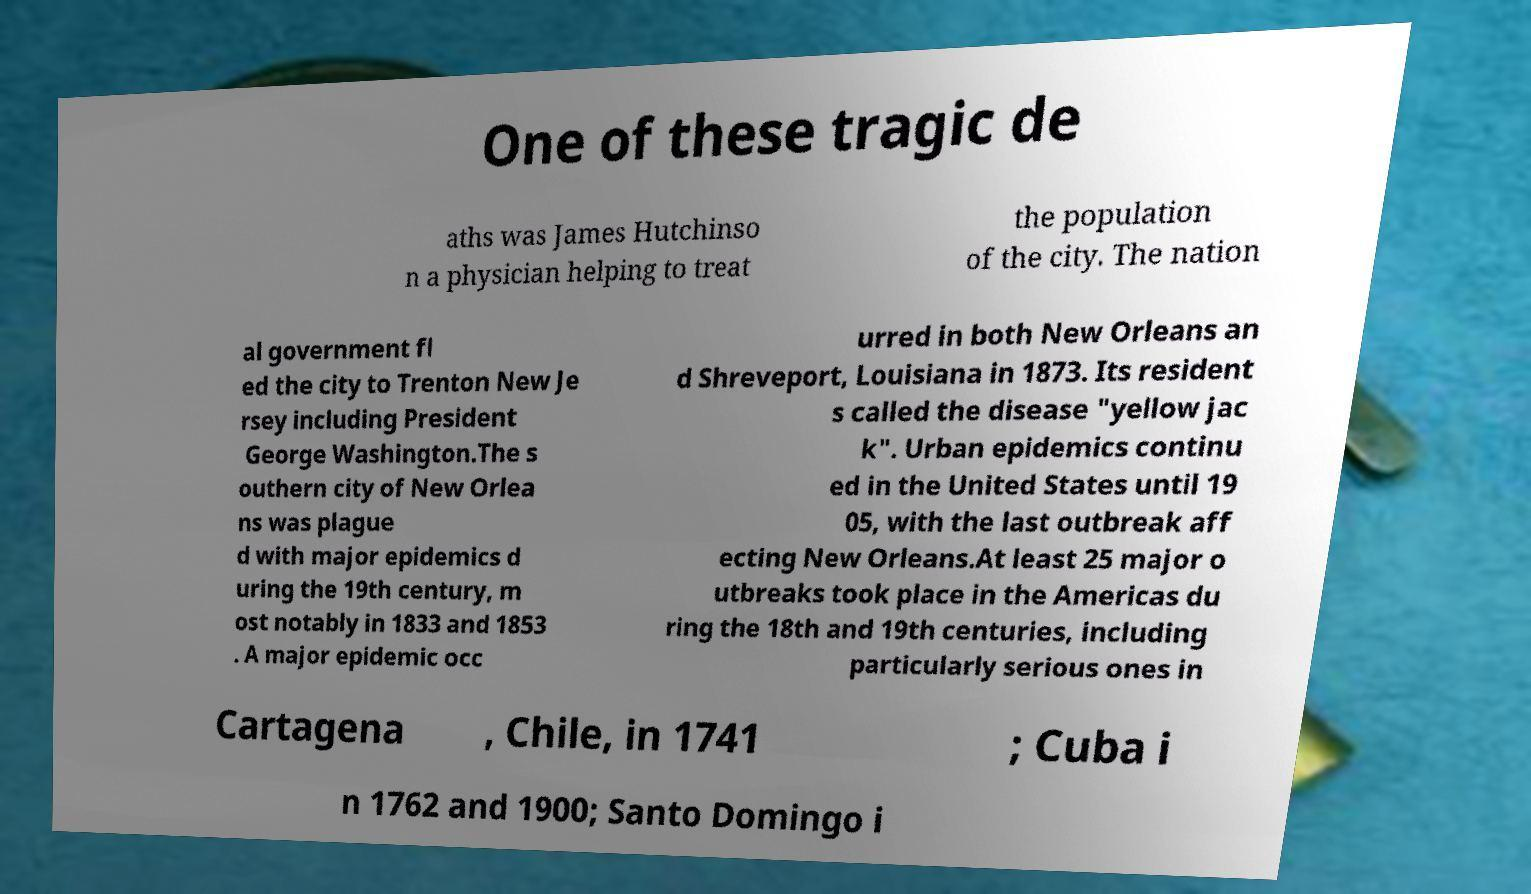Could you extract and type out the text from this image? One of these tragic de aths was James Hutchinso n a physician helping to treat the population of the city. The nation al government fl ed the city to Trenton New Je rsey including President George Washington.The s outhern city of New Orlea ns was plague d with major epidemics d uring the 19th century, m ost notably in 1833 and 1853 . A major epidemic occ urred in both New Orleans an d Shreveport, Louisiana in 1873. Its resident s called the disease "yellow jac k". Urban epidemics continu ed in the United States until 19 05, with the last outbreak aff ecting New Orleans.At least 25 major o utbreaks took place in the Americas du ring the 18th and 19th centuries, including particularly serious ones in Cartagena , Chile, in 1741 ; Cuba i n 1762 and 1900; Santo Domingo i 